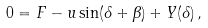<formula> <loc_0><loc_0><loc_500><loc_500>0 = F - u \sin ( \delta + \beta ) + Y ( \delta ) \, ,</formula> 